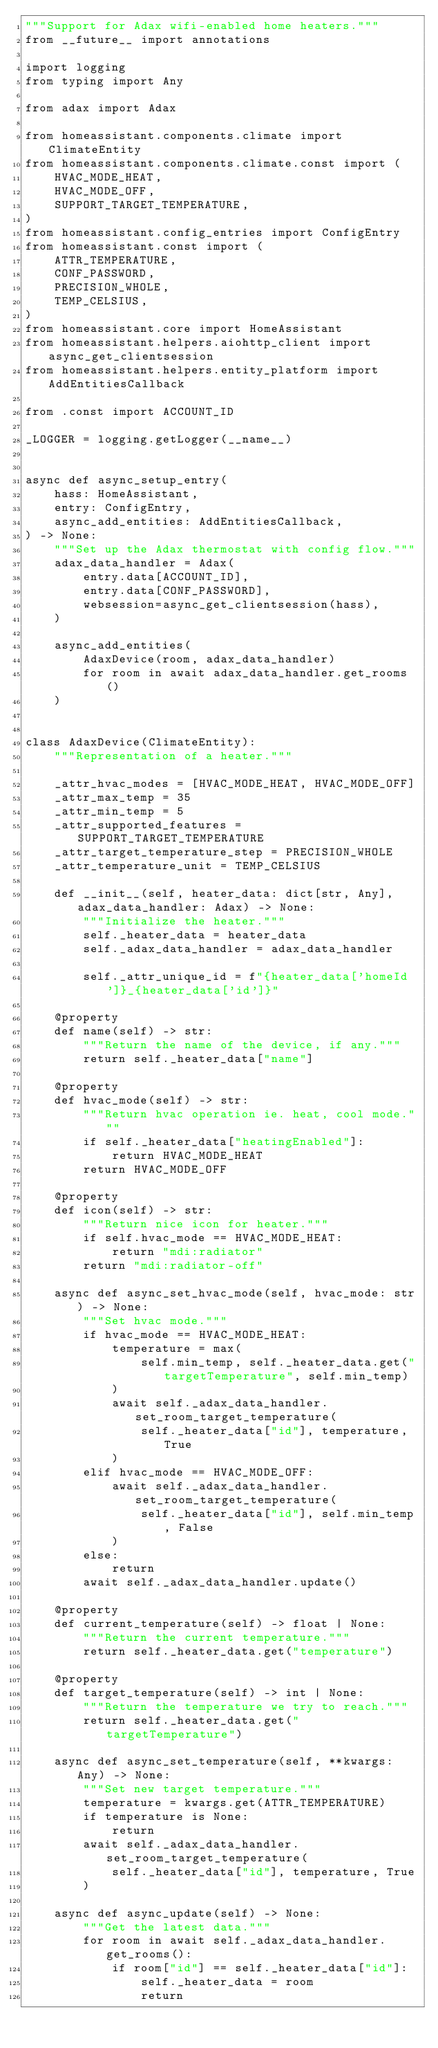<code> <loc_0><loc_0><loc_500><loc_500><_Python_>"""Support for Adax wifi-enabled home heaters."""
from __future__ import annotations

import logging
from typing import Any

from adax import Adax

from homeassistant.components.climate import ClimateEntity
from homeassistant.components.climate.const import (
    HVAC_MODE_HEAT,
    HVAC_MODE_OFF,
    SUPPORT_TARGET_TEMPERATURE,
)
from homeassistant.config_entries import ConfigEntry
from homeassistant.const import (
    ATTR_TEMPERATURE,
    CONF_PASSWORD,
    PRECISION_WHOLE,
    TEMP_CELSIUS,
)
from homeassistant.core import HomeAssistant
from homeassistant.helpers.aiohttp_client import async_get_clientsession
from homeassistant.helpers.entity_platform import AddEntitiesCallback

from .const import ACCOUNT_ID

_LOGGER = logging.getLogger(__name__)


async def async_setup_entry(
    hass: HomeAssistant,
    entry: ConfigEntry,
    async_add_entities: AddEntitiesCallback,
) -> None:
    """Set up the Adax thermostat with config flow."""
    adax_data_handler = Adax(
        entry.data[ACCOUNT_ID],
        entry.data[CONF_PASSWORD],
        websession=async_get_clientsession(hass),
    )

    async_add_entities(
        AdaxDevice(room, adax_data_handler)
        for room in await adax_data_handler.get_rooms()
    )


class AdaxDevice(ClimateEntity):
    """Representation of a heater."""

    _attr_hvac_modes = [HVAC_MODE_HEAT, HVAC_MODE_OFF]
    _attr_max_temp = 35
    _attr_min_temp = 5
    _attr_supported_features = SUPPORT_TARGET_TEMPERATURE
    _attr_target_temperature_step = PRECISION_WHOLE
    _attr_temperature_unit = TEMP_CELSIUS

    def __init__(self, heater_data: dict[str, Any], adax_data_handler: Adax) -> None:
        """Initialize the heater."""
        self._heater_data = heater_data
        self._adax_data_handler = adax_data_handler

        self._attr_unique_id = f"{heater_data['homeId']}_{heater_data['id']}"

    @property
    def name(self) -> str:
        """Return the name of the device, if any."""
        return self._heater_data["name"]

    @property
    def hvac_mode(self) -> str:
        """Return hvac operation ie. heat, cool mode."""
        if self._heater_data["heatingEnabled"]:
            return HVAC_MODE_HEAT
        return HVAC_MODE_OFF

    @property
    def icon(self) -> str:
        """Return nice icon for heater."""
        if self.hvac_mode == HVAC_MODE_HEAT:
            return "mdi:radiator"
        return "mdi:radiator-off"

    async def async_set_hvac_mode(self, hvac_mode: str) -> None:
        """Set hvac mode."""
        if hvac_mode == HVAC_MODE_HEAT:
            temperature = max(
                self.min_temp, self._heater_data.get("targetTemperature", self.min_temp)
            )
            await self._adax_data_handler.set_room_target_temperature(
                self._heater_data["id"], temperature, True
            )
        elif hvac_mode == HVAC_MODE_OFF:
            await self._adax_data_handler.set_room_target_temperature(
                self._heater_data["id"], self.min_temp, False
            )
        else:
            return
        await self._adax_data_handler.update()

    @property
    def current_temperature(self) -> float | None:
        """Return the current temperature."""
        return self._heater_data.get("temperature")

    @property
    def target_temperature(self) -> int | None:
        """Return the temperature we try to reach."""
        return self._heater_data.get("targetTemperature")

    async def async_set_temperature(self, **kwargs: Any) -> None:
        """Set new target temperature."""
        temperature = kwargs.get(ATTR_TEMPERATURE)
        if temperature is None:
            return
        await self._adax_data_handler.set_room_target_temperature(
            self._heater_data["id"], temperature, True
        )

    async def async_update(self) -> None:
        """Get the latest data."""
        for room in await self._adax_data_handler.get_rooms():
            if room["id"] == self._heater_data["id"]:
                self._heater_data = room
                return
</code> 